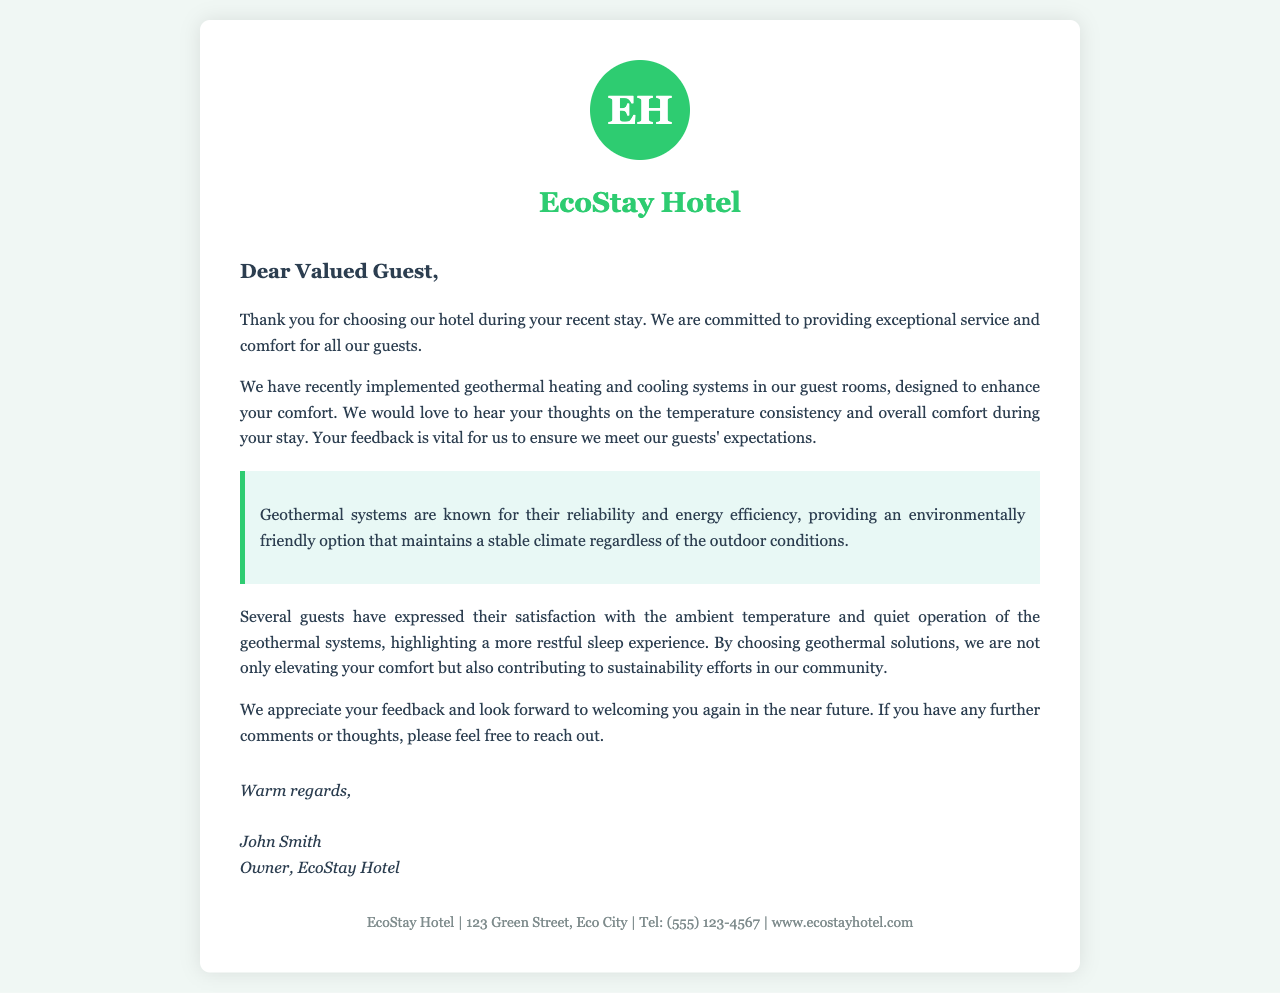what is the name of the hotel? The name of the hotel is mentioned at the beginning of the letter as "EcoStay Hotel."
Answer: EcoStay Hotel who is the owner of the hotel? The letter is signed by John Smith, indicating that he is the owner of EcoStay Hotel.
Answer: John Smith what is the main focus of the letter? The letter focuses on gathering feedback from guests regarding the geothermal heating and cooling systems implemented in the hotel.
Answer: Customer feedback on geothermal systems how does the letter describe geothermal systems? The letter describes geothermal systems as reliable and energy efficient options for maintaining stable climate conditions.
Answer: Reliable and energy efficient what is the primary benefit highlighted in the letter for using geothermal systems? The primary benefit highlighted is the enhanced comfort and stable climate provided by geothermal systems during guests' stays.
Answer: Enhanced comfort how does the letter suggest guests can provide feedback? The letter encourages guests to reach out with their comments or thoughts, implying a direct method for feedback.
Answer: By reaching out how is guest satisfaction with the heating system characterized? The letter mentions that several guests have expressed satisfaction with the ambient temperature and quiet operation of the geothermal systems.
Answer: Satisfaction with temperature and quiet operation what address is listed for EcoStay Hotel? The document includes the address for EcoStay Hotel, which is stated as "123 Green Street, Eco City."
Answer: 123 Green Street, Eco City what is included in the logo design mentioned in the letter? The letter describes a logo design that consists of the letters "EH" within a circular background.
Answer: EH in a circular background 